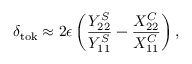<formula> <loc_0><loc_0><loc_500><loc_500>\delta _ { t o k } \approx 2 \epsilon \left ( \frac { Y _ { 2 2 } ^ { S } } { Y _ { 1 1 } ^ { S } } - \frac { X _ { 2 2 } ^ { C } } { X _ { 1 1 } ^ { C } } \right ) ,</formula> 